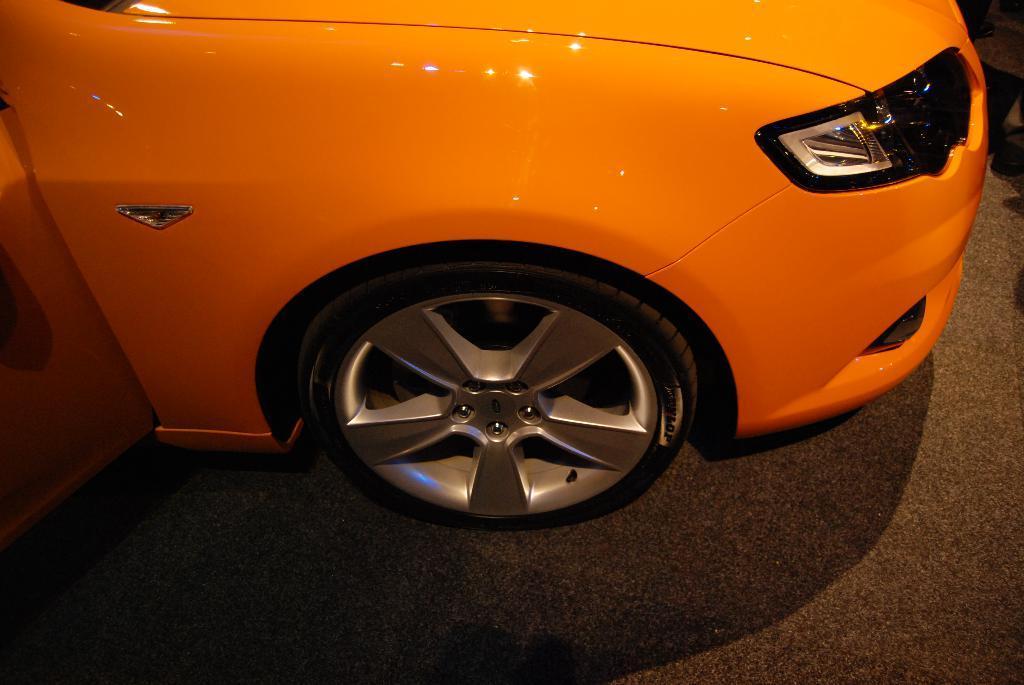How would you summarize this image in a sentence or two? In the image we can see a vehicle. 